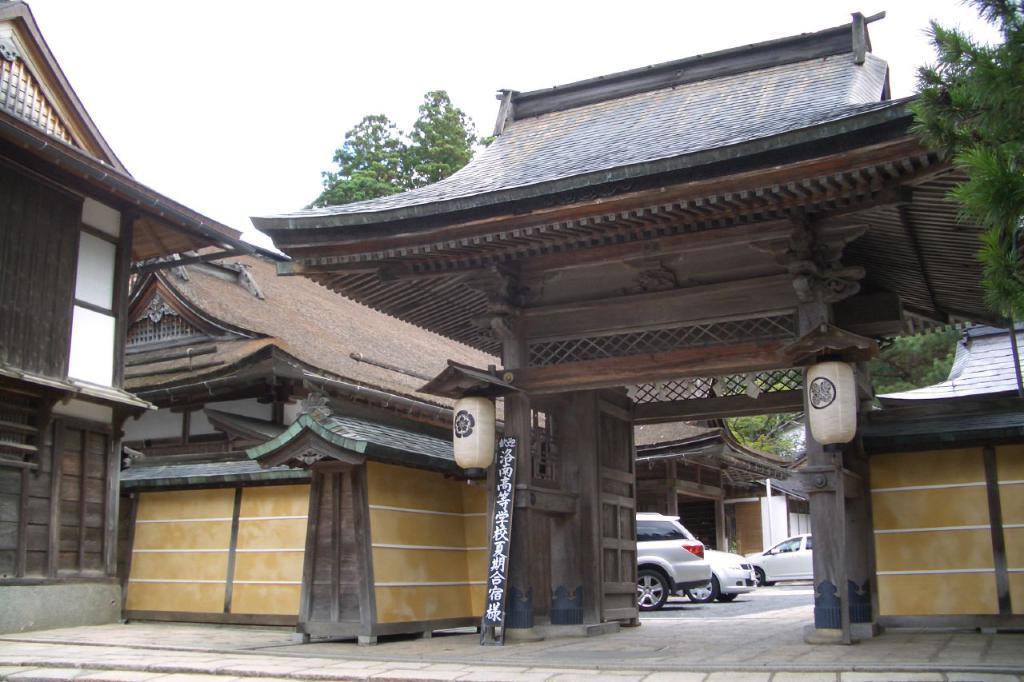Can you describe this image briefly? In this image we can see there is a building, beside the building there are trees. In front of the buildings there are some vehicles parked. In the background there is a sky. 